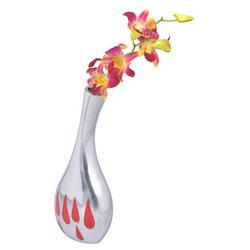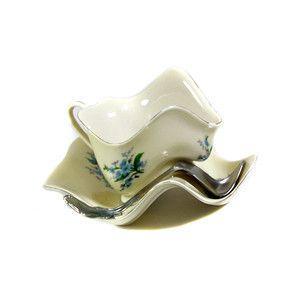The first image is the image on the left, the second image is the image on the right. Considering the images on both sides, is "In at least one image there is a single white vase that expanse at the top." valid? Answer yes or no. No. The first image is the image on the left, the second image is the image on the right. Assess this claim about the two images: "There is a vase with a wide bottom that tapers to be smaller at the opening holding a single plant in it". Correct or not? Answer yes or no. Yes. 